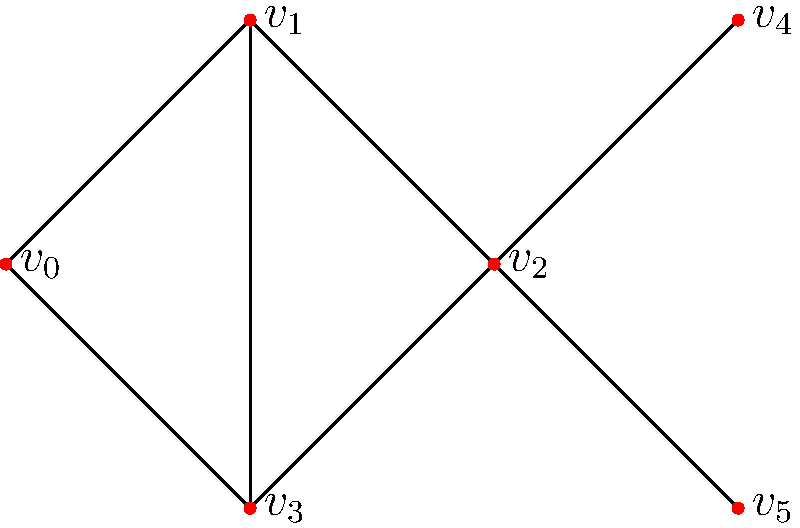Given the graph representation of system log dependencies, calculate the betweenness centrality of node $v_2$. Assume all paths are equally weighted. To calculate the betweenness centrality of node $v_2$, we need to follow these steps:

1. Identify all pairs of nodes that have shortest paths passing through $v_2$.
2. For each pair, calculate the fraction of shortest paths that pass through $v_2$.
3. Sum up all these fractions.

Let's analyze the pairs:

a) $v_0$ to $v_4$ and $v_5$: All paths must go through $v_2$. (2 pairs)
b) $v_1$ to $v_4$ and $v_5$: All paths must go through $v_2$. (2 pairs)
c) $v_3$ to $v_4$ and $v_5$: All paths must go through $v_2$. (2 pairs)
d) $v_4$ to $v_5$: The only path is through $v_2$. (1 pair)

For each of these 7 pairs, there is only one shortest path, and it always includes $v_2$. So, the fraction for each pair is 1.

The betweenness centrality is the sum of these fractions:

$$1 + 1 + 1 + 1 + 1 + 1 + 1 = 7$$

This value represents the absolute betweenness centrality. To normalize it, we would divide by the total number of pairs of nodes excluding $v_2$, which is $\frac{5 * 4}{2} = 10$.

Normalized betweenness centrality = $\frac{7}{10} = 0.7$
Answer: 0.7 